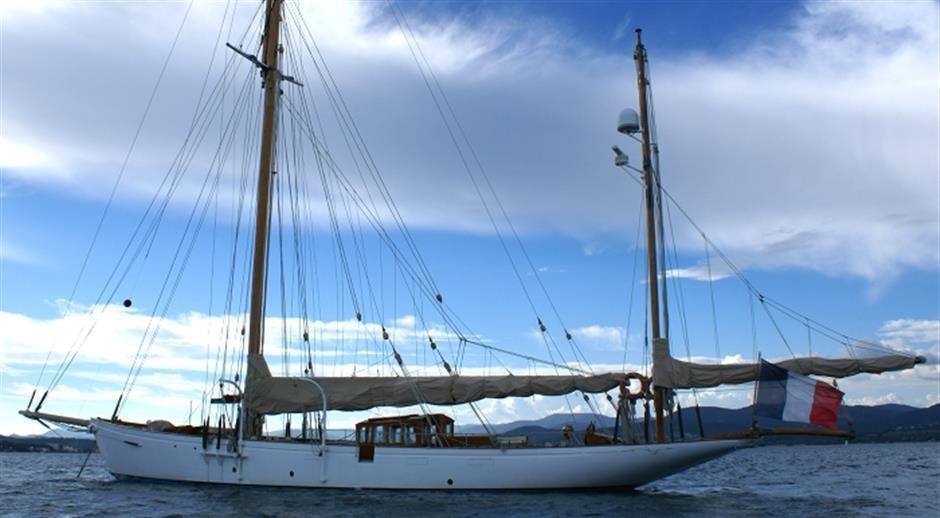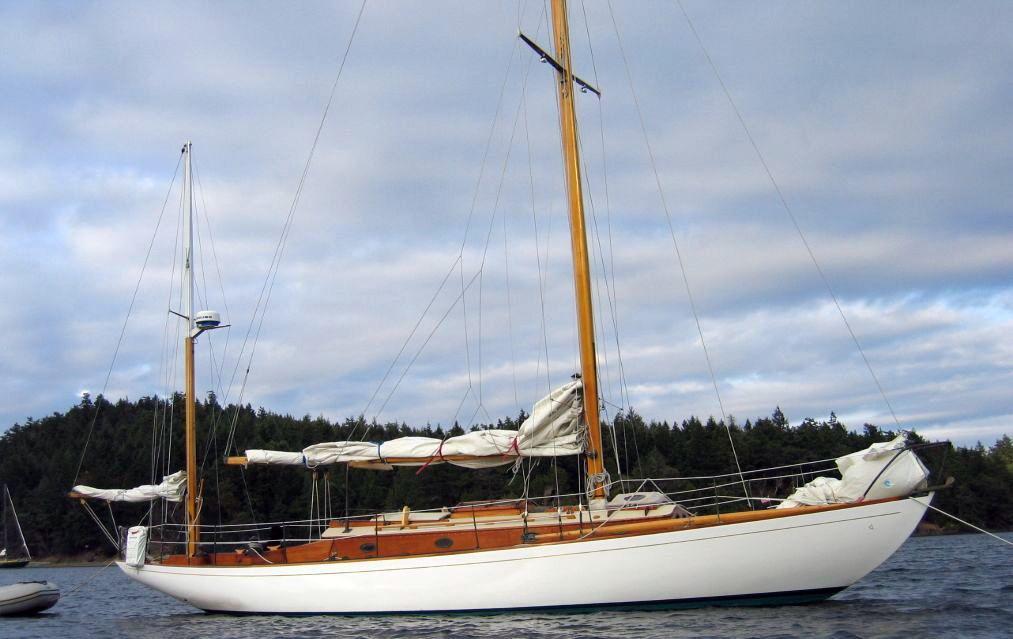The first image is the image on the left, the second image is the image on the right. Considering the images on both sides, is "All boat sails are furled." valid? Answer yes or no. Yes. The first image is the image on the left, the second image is the image on the right. Assess this claim about the two images: "the sails are furled in the image on the right". Correct or not? Answer yes or no. Yes. 